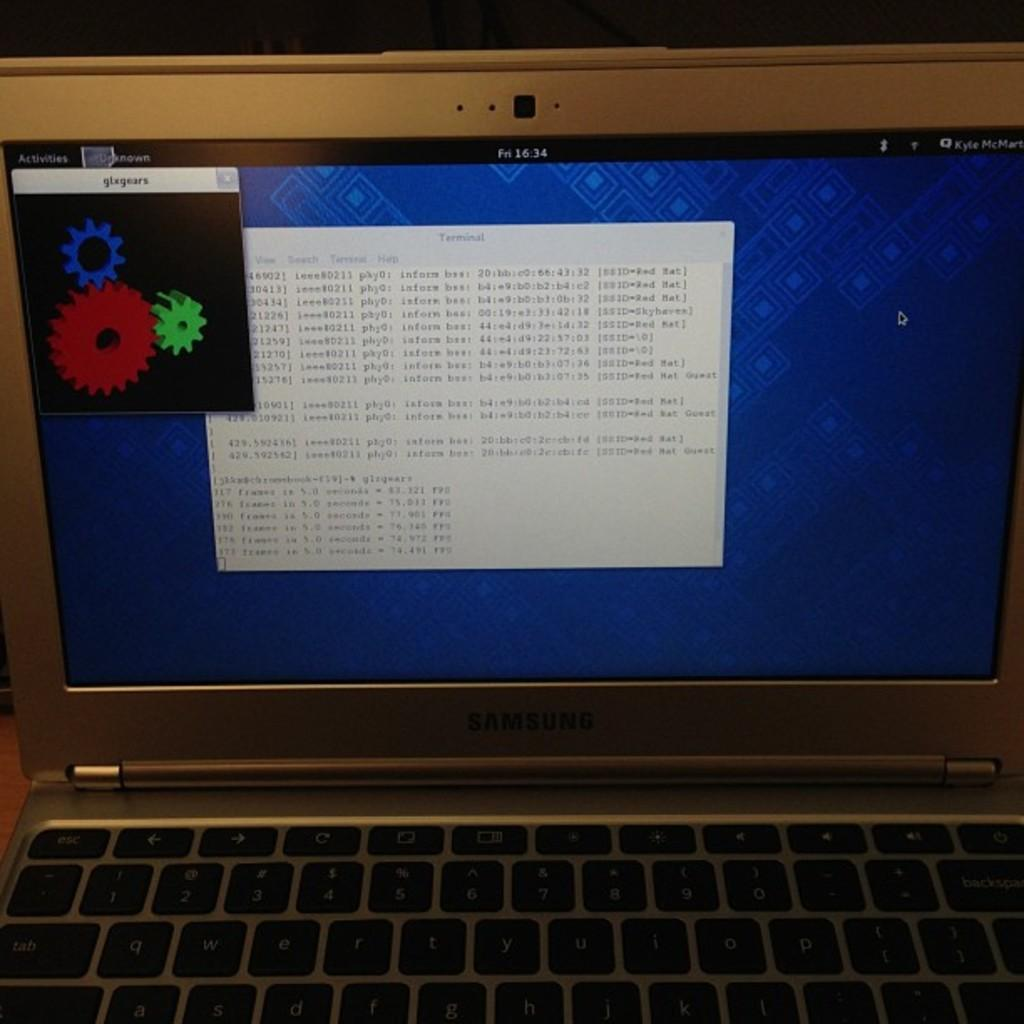Provide a one-sentence caption for the provided image. A laptop screen has fn1634 on the black border of the display. 